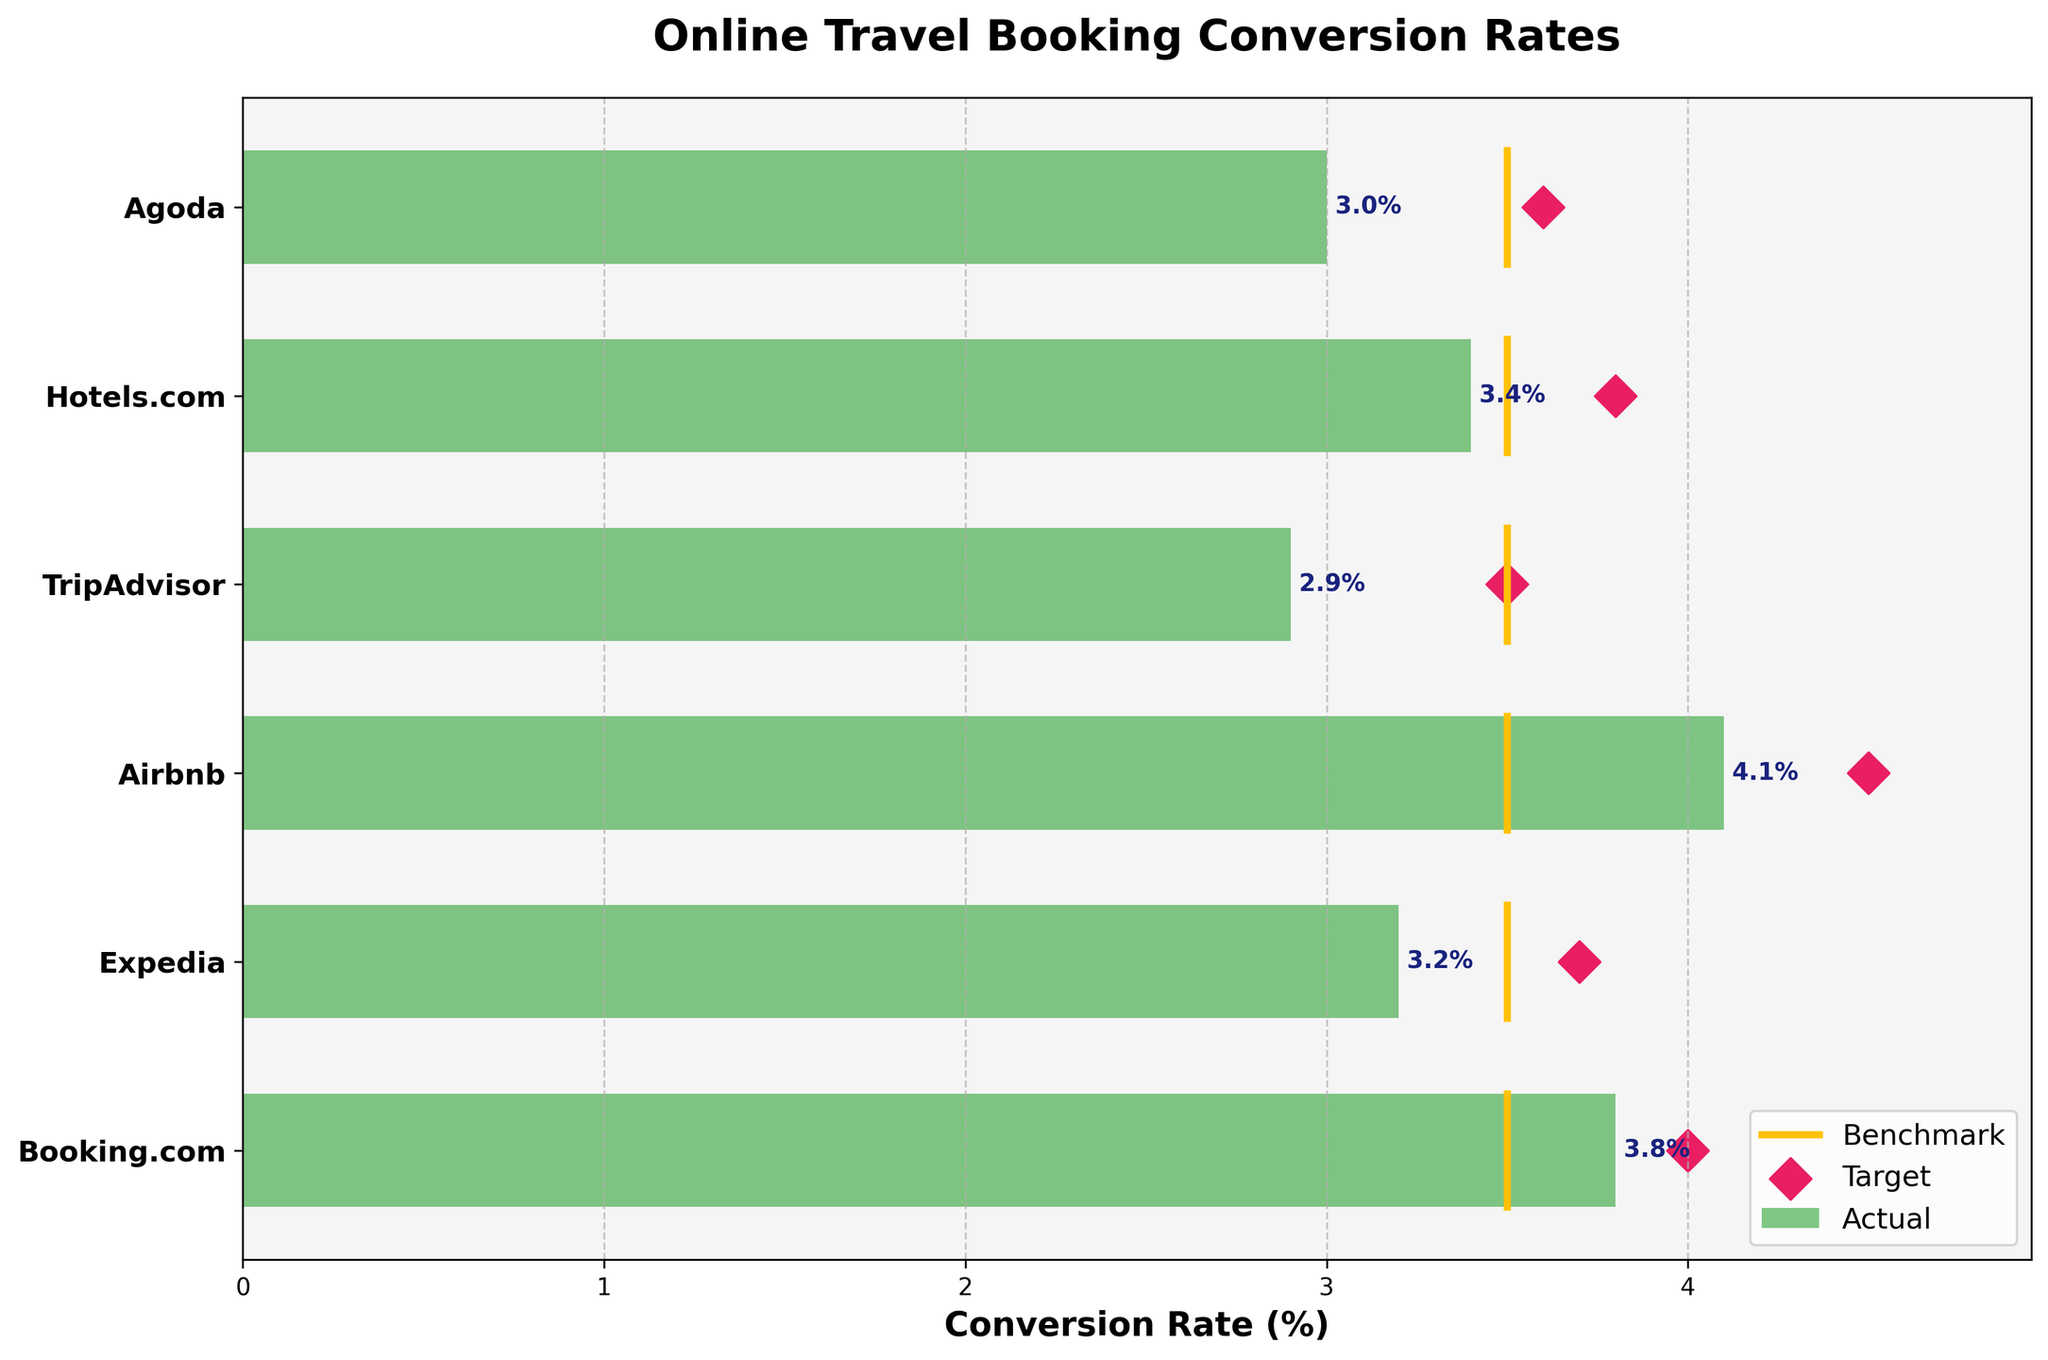Which platform has the highest actual conversion rate? The actual conversion rates for all platforms are shown in the bar chart. Identify the highest value among these bars, which is 4.1 for Airbnb.
Answer: Airbnb What is the industry benchmark conversion rate? According to the plot, the fixed industry benchmark for all platforms is indicated by the yellow lines, which are all positioned at 3.5.
Answer: 3.5 How does TripAdvisor's actual conversion rate compare to its target? Locate TripAdvisor's actual conversion rate (2.9) and its target (3.5). The actual rate (2.9) is lower than its target (3.5).
Answer: Lower Which platforms have actual conversion rates above the industry benchmark? Compare the actual conversion rates for each platform with the industry benchmark (3.5). Both Airbnb (4.1) and Booking.com (3.8) have conversion rates above this benchmark.
Answer: Airbnb, Booking.com What is the difference between the actual and target conversion rates for Airbnb? Find Airbnb's actual conversion rate (4.1) and its target (4.5). The difference is calculated as 4.5 - 4.1 = 0.4.
Answer: 0.4 How many platforms are shown in the chart? Count the number of data points plotted along the y-axis of the chart, corresponding to the platforms. There are 6 platforms displayed.
Answer: 6 Does Agoda meet its target conversion rate? Check Agoda's actual conversion rate (3.0) against its target (3.6). Since 3.0 is less than 3.6, it does not meet its target.
Answer: No What is the average actual conversion rate of all platforms? Add the actual conversion rates of all platforms (3.8 + 3.2 + 4.1 + 2.9 + 3.4 + 3.0) to get 20.4. Then divide by the number of platforms (6) to get the average (20.4 / 6 = 3.4).
Answer: 3.4 Which platform is closest to meeting its target conversion rate but falls short? Examine each platform’s actual and target conversion rates, calculate the difference, and identify the smallest positive difference:
- Booking.com: Target 4.0, Actual 3.8, Difference 0.2
- Expedia: Target 3.7, Actual 3.2, Difference 0.5
- Airbnb: Target 4.5, Actual 4.1, Difference 0.4
- TripAdvisor: Target 3.5, Actual 2.9, Difference 0.6
- Hotels.com: Target 3.8, Actual 3.4, Difference 0.4
- Agoda: Target 3.6, Actual 3.0, Difference 0.6 
Booking.com has the smallest difference of 0.2.
Answer: Booking.com What is the combined target conversion rate for all platforms? Sum the target conversion rates of all platforms (4.0 + 3.7 + 4.5 + 3.5 + 3.8 + 3.6), which equals 23.1.
Answer: 23.1 